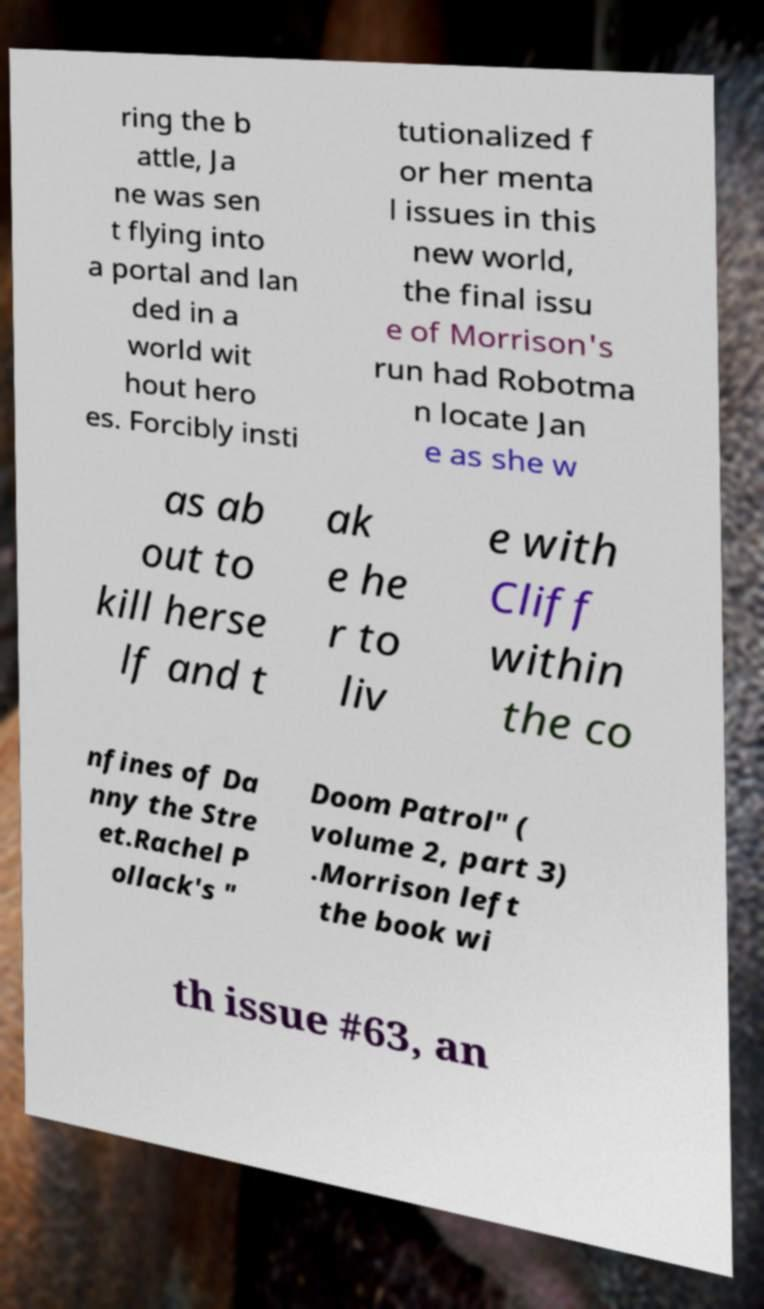Could you extract and type out the text from this image? ring the b attle, Ja ne was sen t flying into a portal and lan ded in a world wit hout hero es. Forcibly insti tutionalized f or her menta l issues in this new world, the final issu e of Morrison's run had Robotma n locate Jan e as she w as ab out to kill herse lf and t ak e he r to liv e with Cliff within the co nfines of Da nny the Stre et.Rachel P ollack's " Doom Patrol" ( volume 2, part 3) .Morrison left the book wi th issue #63, an 